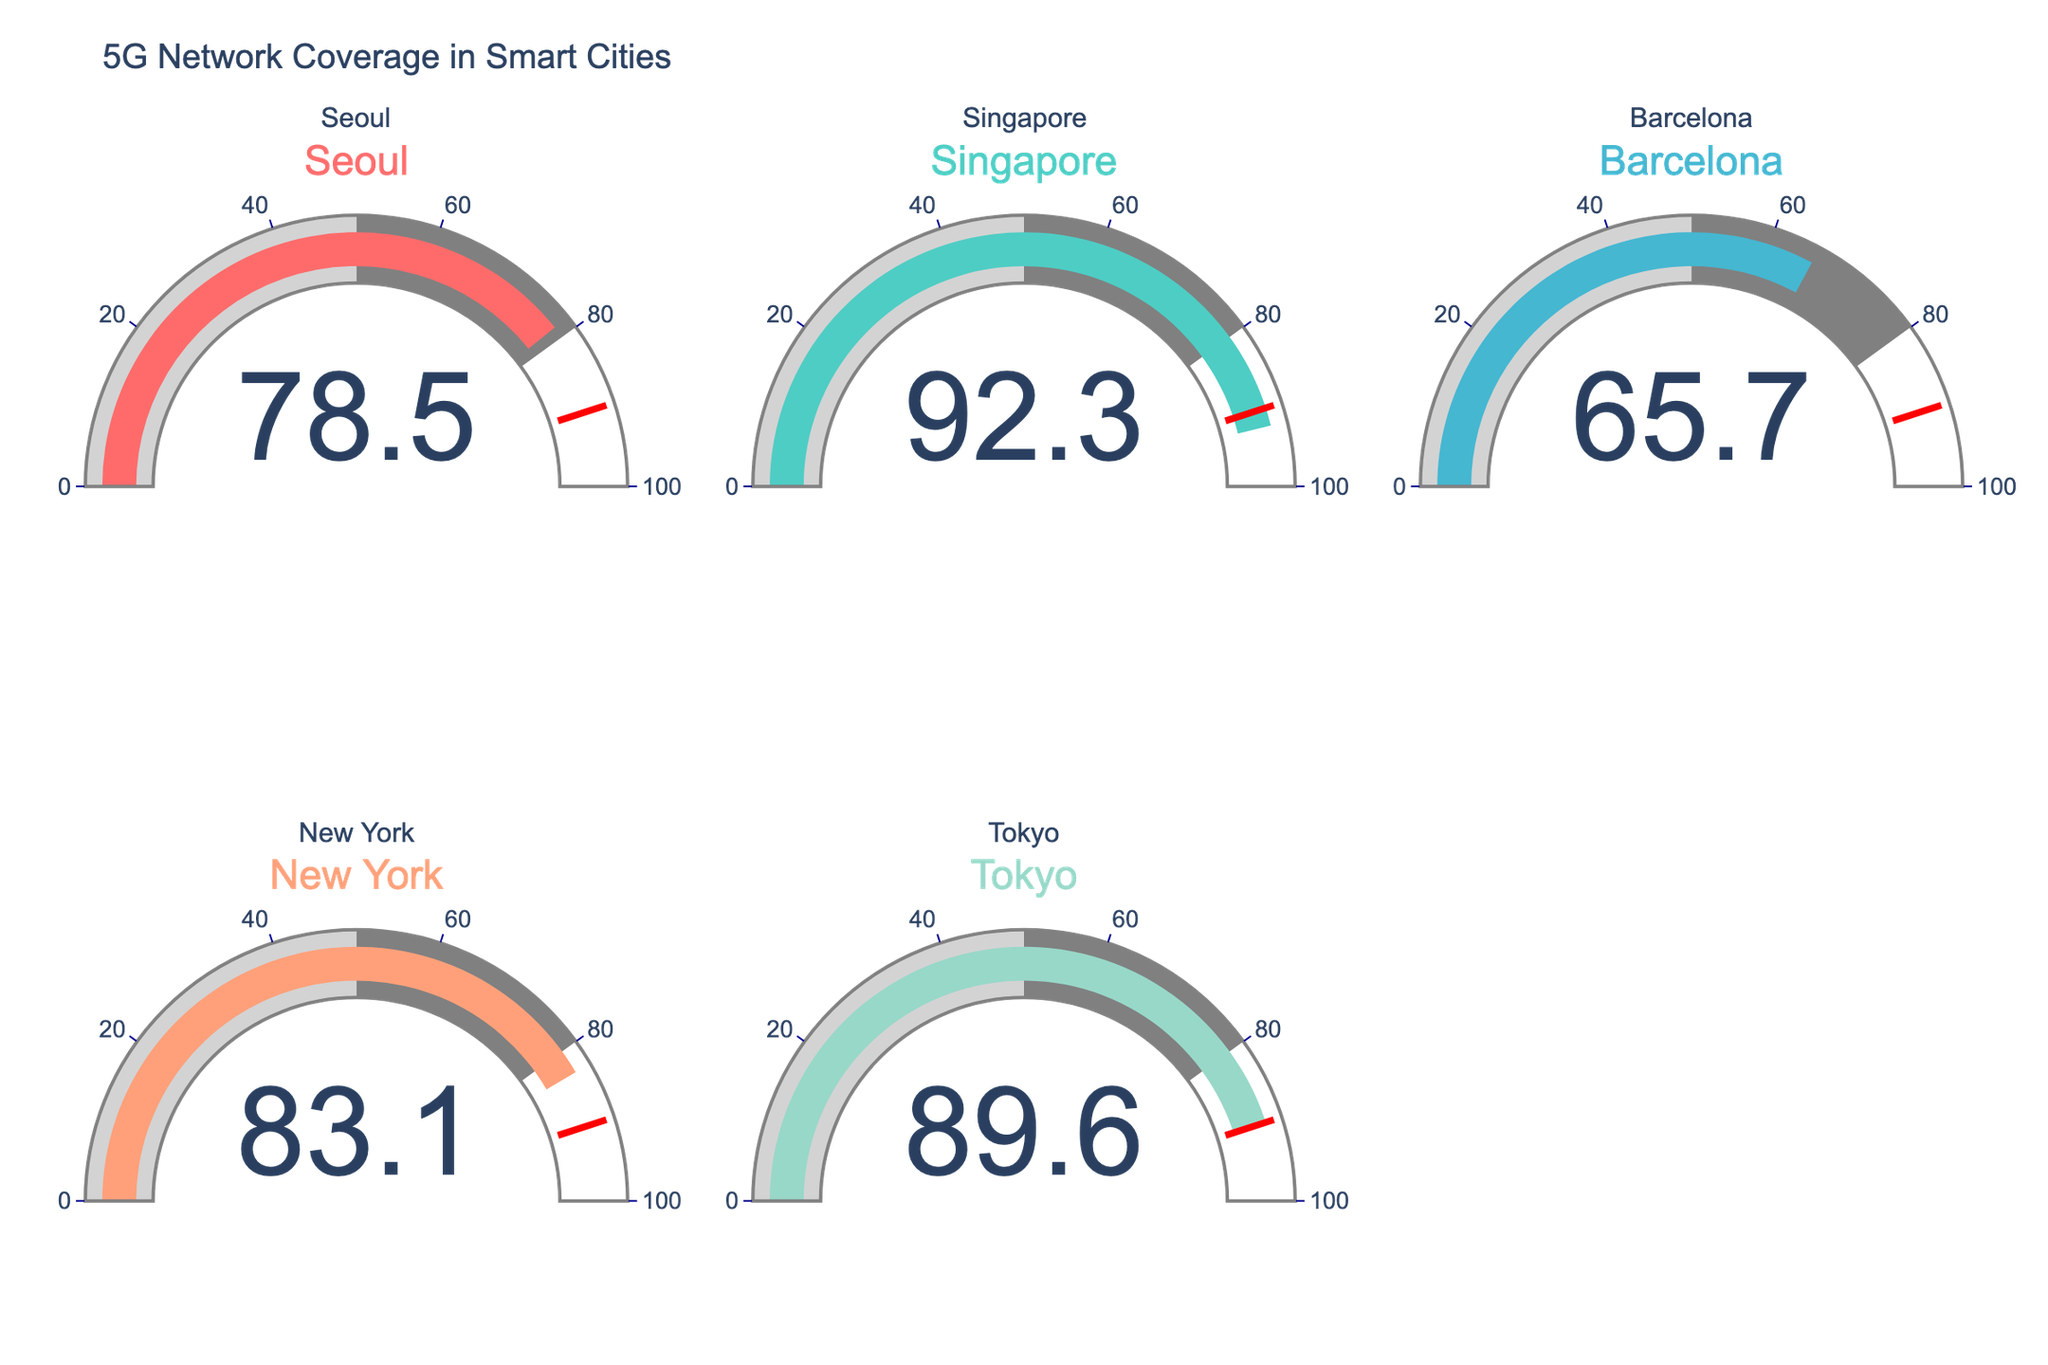What's the title of the figure? The title is prominently displayed at the top of the figure and provides a summary of the data being visualized.
Answer: 5G Network Coverage in Smart Cities How many cities are shown in the figure? The figure displays a gauge chart for each city. By counting the number of gauges or titles, we can determine the number of cities.
Answer: 5 Which city has the highest 5G Coverage Percentage? By examining the values on each gauge, the city with the highest number will have the highest coverage percentage.
Answer: Singapore Which city has the lowest 5G Coverage Percentage? By checking the values on each gauge, the city with the lowest number will have the lowest coverage percentage.
Answer: Barcelona What is the range of 5G coverage percentages across all cities? Determine the highest and lowest coverage percentages shown in the figure, then subtract the lowest from the highest to get the range.
Answer: 92.3% to 65.7%, so the range is 26.6% What's the average 5G Coverage Percentage of all the cities? Add all the percentages together and divide by the number of cities to find the average. (78.5 + 92.3 + 65.7 + 83.1 + 89.6) / 5 = 81.84
Answer: 81.84% What's the combined 5G Coverage Percentage for Seoul, Tokyo, and New York? Add the coverage percentages for Seoul, Tokyo, and New York together. 78.5 + 89.6 + 83.1 = 251.2
Answer: 251.2 Is there any city with a 5G coverage percentage above the threshold value of 90% that is marked in the figure? The figure highlights thresholds using visual markers. Compare each city's coverage percentage to see if it surpasses the 90% threshold.
Answer: Yes, Singapore at 92.3% Which city has a 5G coverage percentage just below 90%? Check each gauge to find the value closest to but not exceeding 90%.
Answer: Tokyo with 89.6% How much higher is the 5G coverage in New York compared to Barcelona? Subtract Barcelona's coverage percentage from New York's coverage percentage to determine the difference. 83.1 - 65.7 = 17.4
Answer: 17.4% 